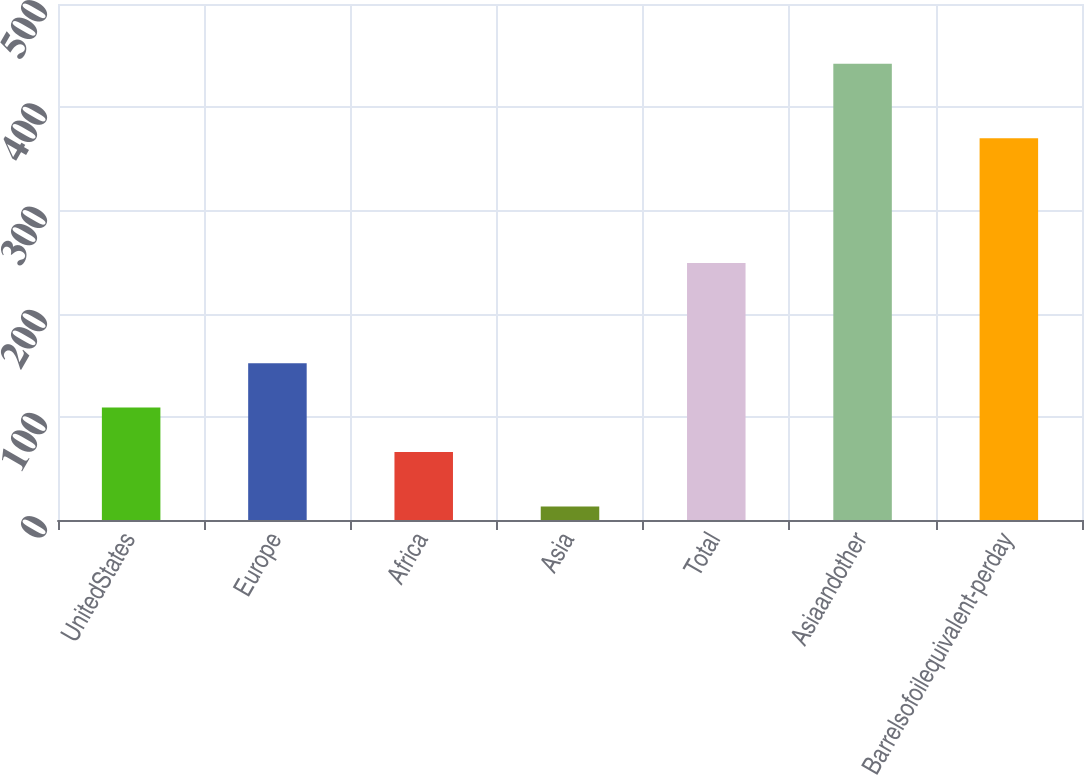Convert chart to OTSL. <chart><loc_0><loc_0><loc_500><loc_500><bar_chart><fcel>UnitedStates<fcel>Europe<fcel>Africa<fcel>Asia<fcel>Total<fcel>Asiaandother<fcel>Barrelsofoilequivalent-perday<nl><fcel>108.9<fcel>151.8<fcel>66<fcel>13<fcel>249<fcel>442<fcel>370<nl></chart> 